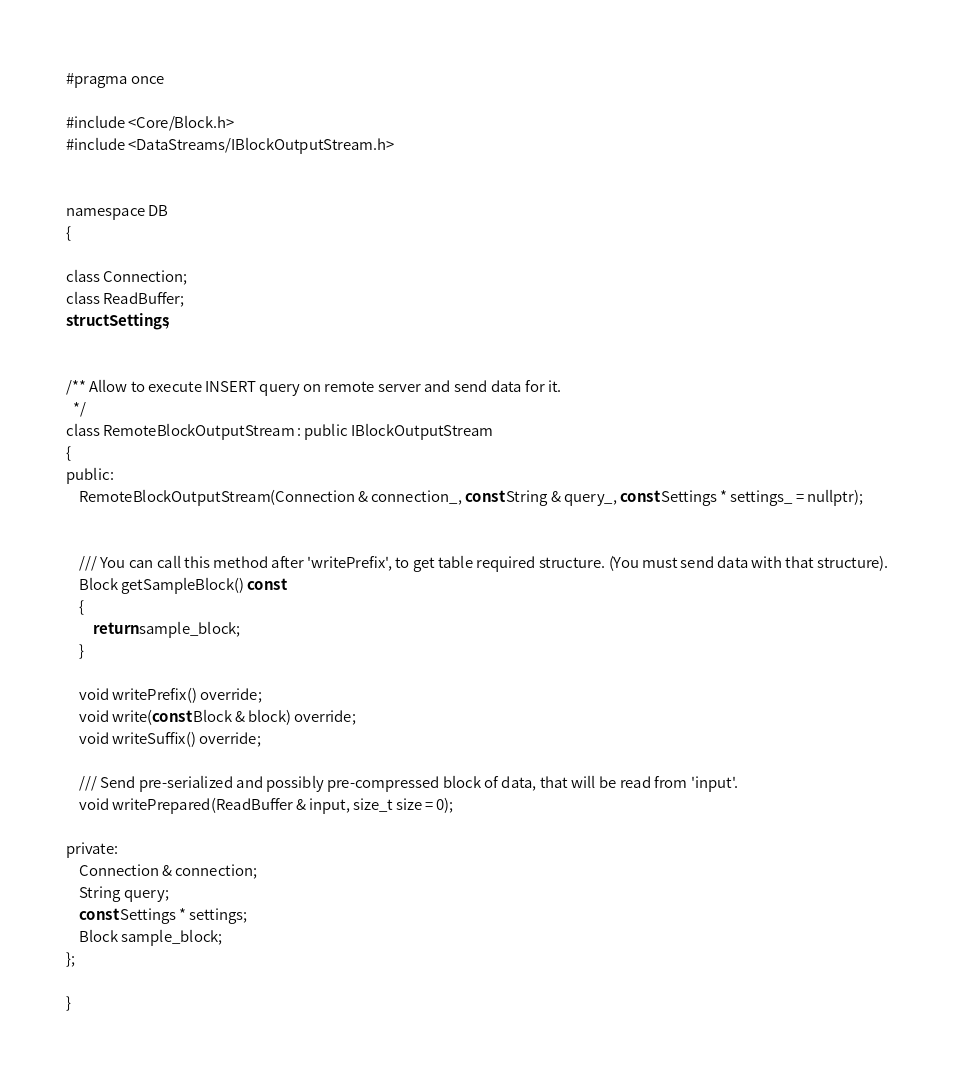<code> <loc_0><loc_0><loc_500><loc_500><_C_>#pragma once

#include <Core/Block.h>
#include <DataStreams/IBlockOutputStream.h>


namespace DB
{

class Connection;
class ReadBuffer;
struct Settings;


/** Allow to execute INSERT query on remote server and send data for it.
  */
class RemoteBlockOutputStream : public IBlockOutputStream
{
public:
    RemoteBlockOutputStream(Connection & connection_, const String & query_, const Settings * settings_ = nullptr);


    /// You can call this method after 'writePrefix', to get table required structure. (You must send data with that structure).
    Block getSampleBlock() const
    {
        return sample_block;
    }

    void writePrefix() override;
    void write(const Block & block) override;
    void writeSuffix() override;

    /// Send pre-serialized and possibly pre-compressed block of data, that will be read from 'input'.
    void writePrepared(ReadBuffer & input, size_t size = 0);

private:
    Connection & connection;
    String query;
    const Settings * settings;
    Block sample_block;
};

}
</code> 